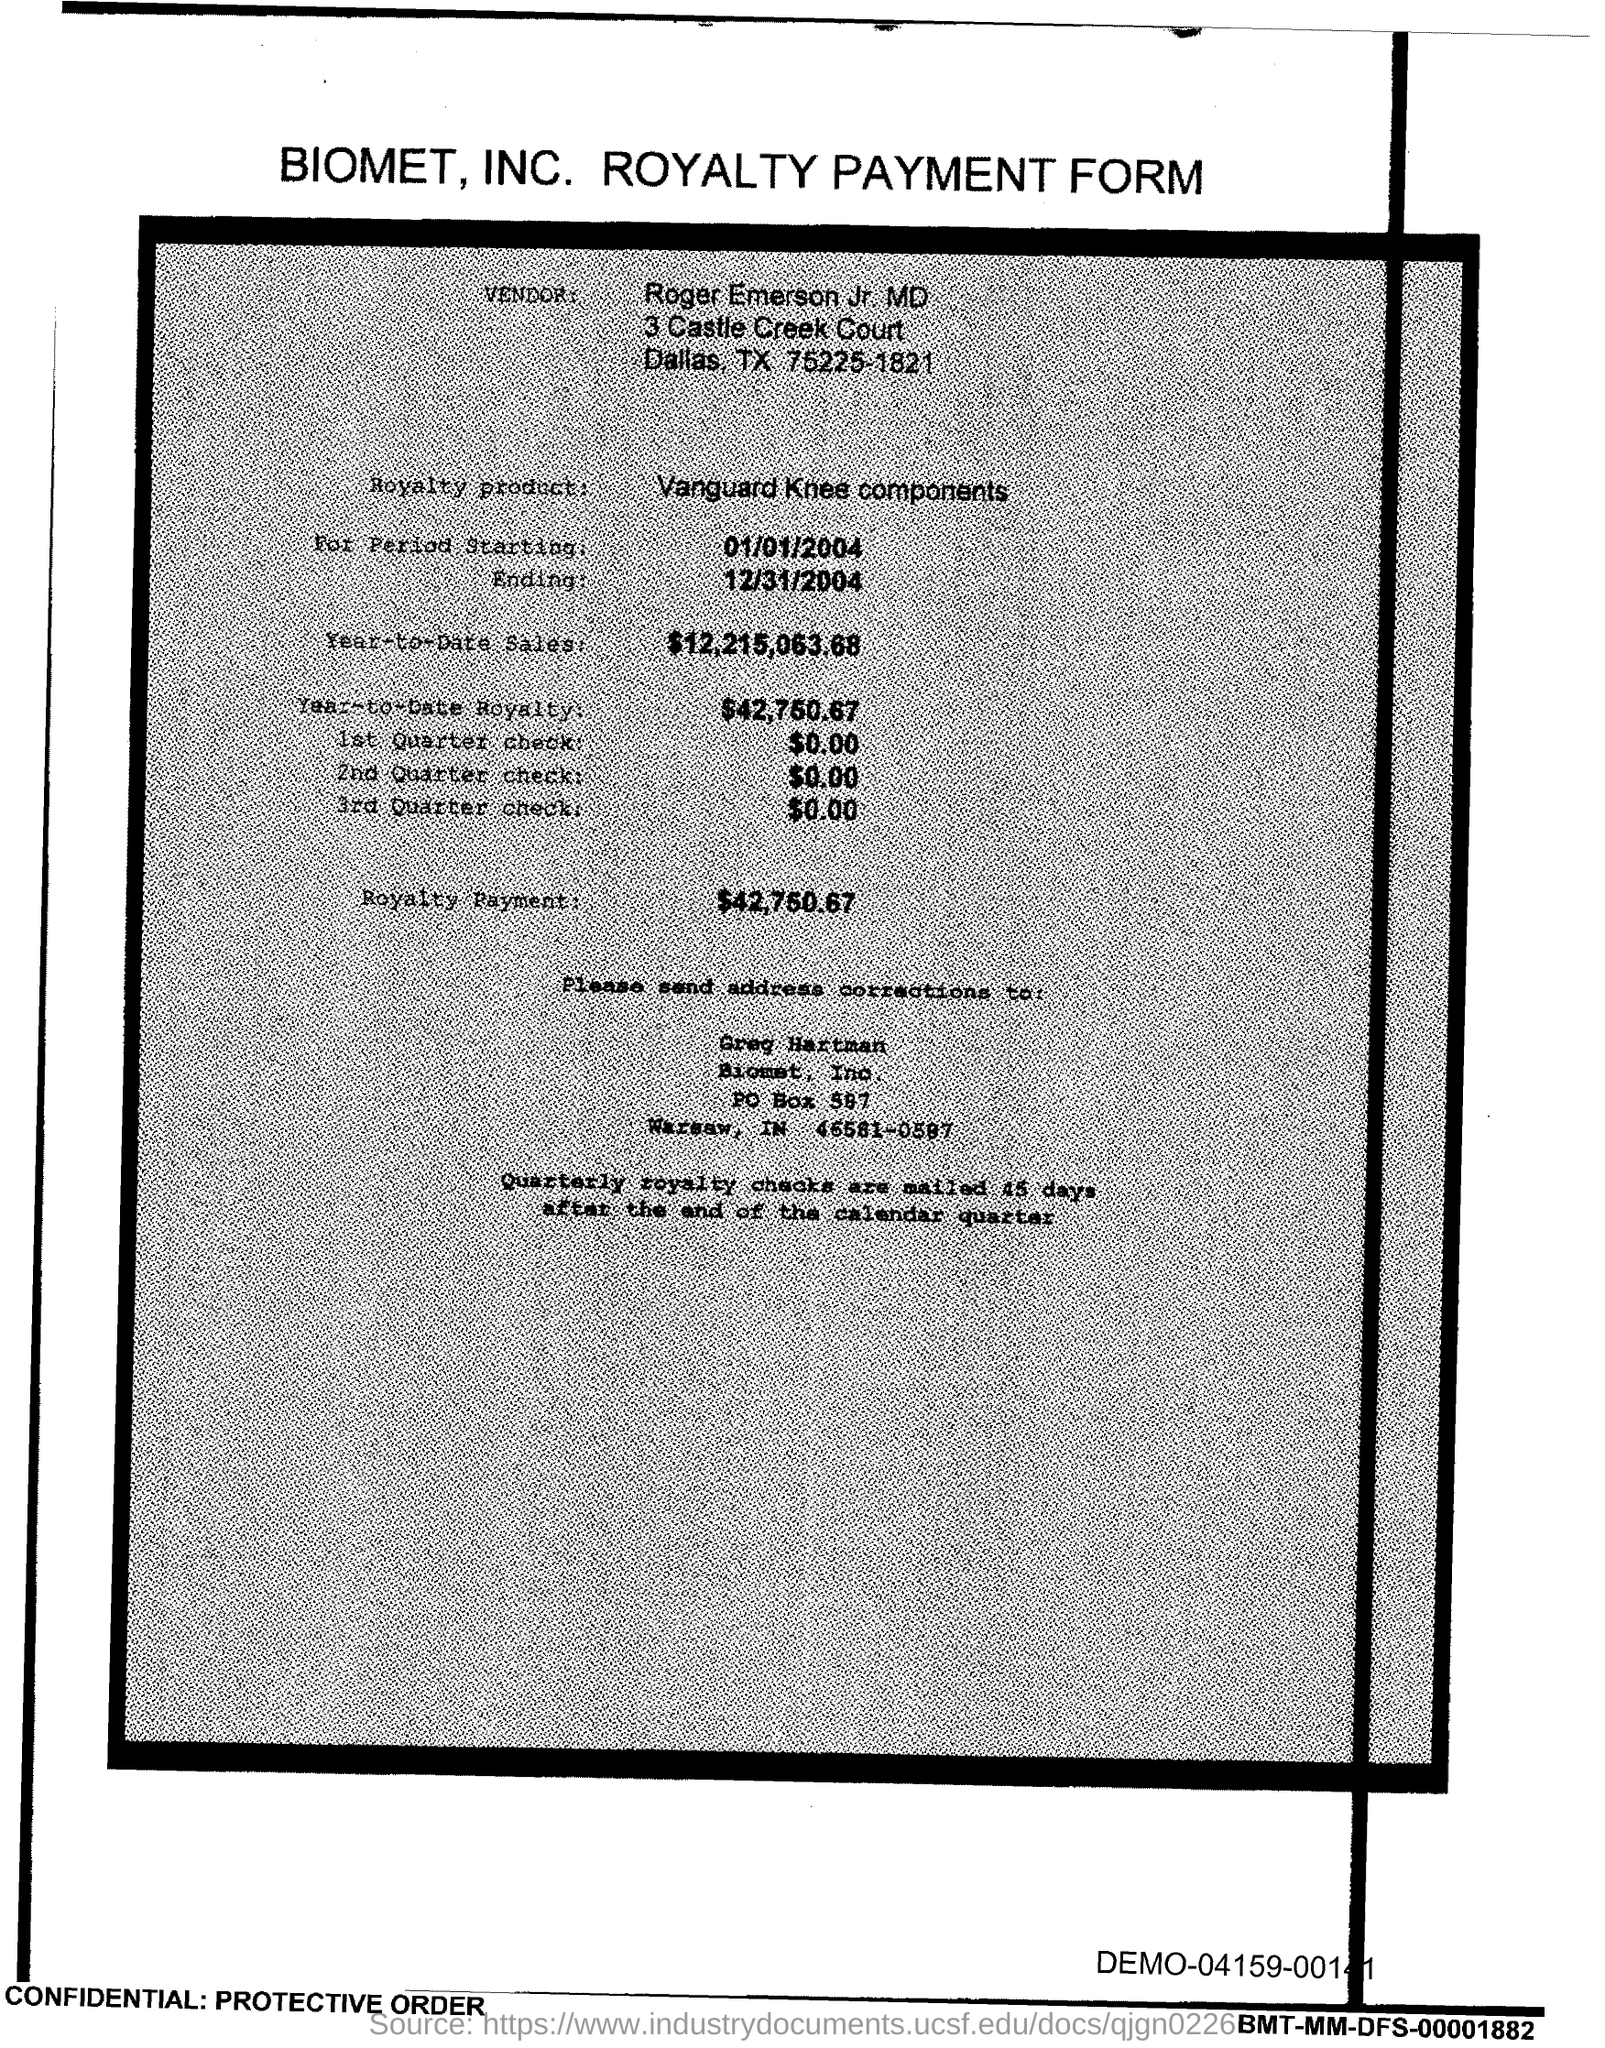Identify some key points in this picture. The amount mentioned in the 2nd Quarter check form is $0.00. Greg Hartman is responsible for address corrections. The end date of the royalty period is December 31, 2004. The amount mentioned on the first quarter check form is $0.00. The start date of the royalty period is January 1, 2004. 